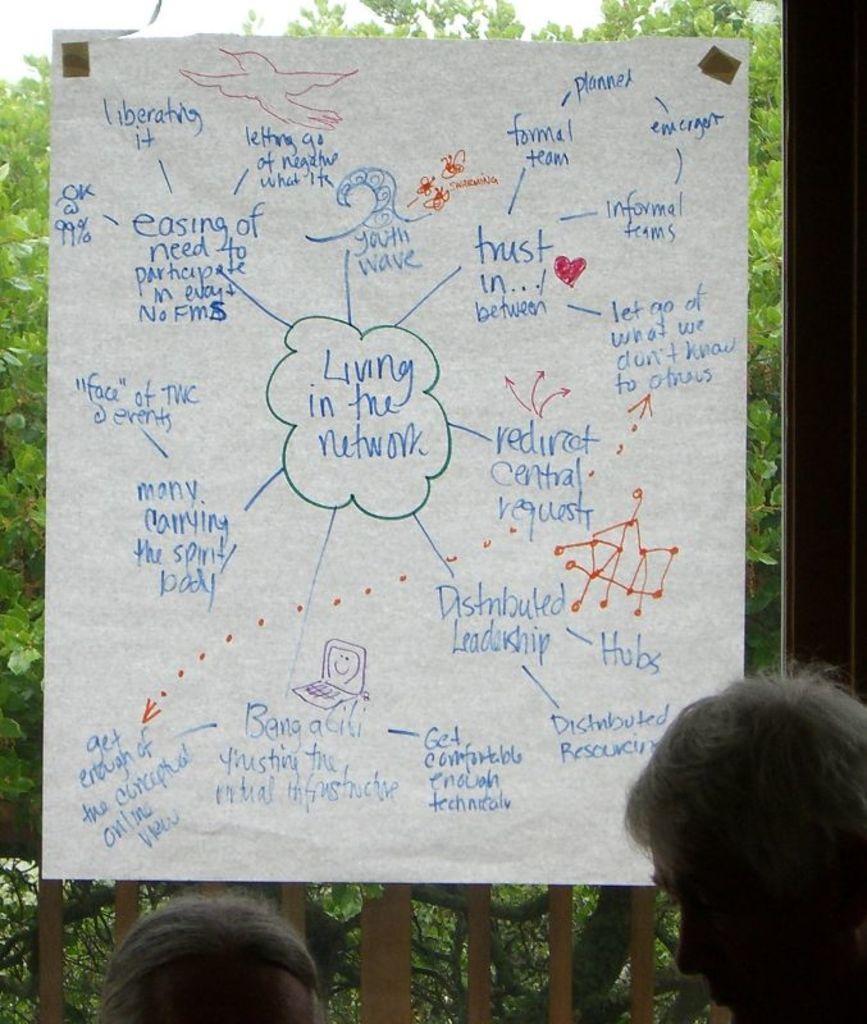In one or two sentences, can you explain what this image depicts? In this image there is one glass door on the door there is one paper, and on the paper there is some text and through the door we could see some trees. At the bottom there are two people. 